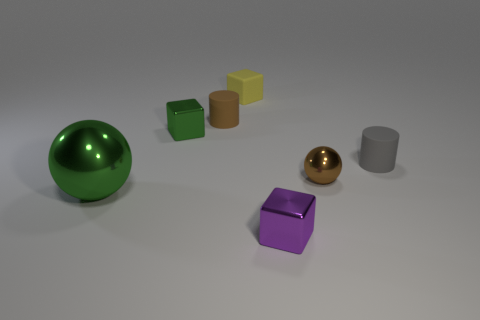Subtract all metal blocks. How many blocks are left? 1 Add 1 green metallic spheres. How many objects exist? 8 Subtract all brown blocks. Subtract all brown cylinders. How many blocks are left? 3 Subtract all balls. How many objects are left? 5 Add 1 rubber cylinders. How many rubber cylinders exist? 3 Subtract 0 red cubes. How many objects are left? 7 Subtract all green things. Subtract all rubber cylinders. How many objects are left? 3 Add 6 purple metallic blocks. How many purple metallic blocks are left? 7 